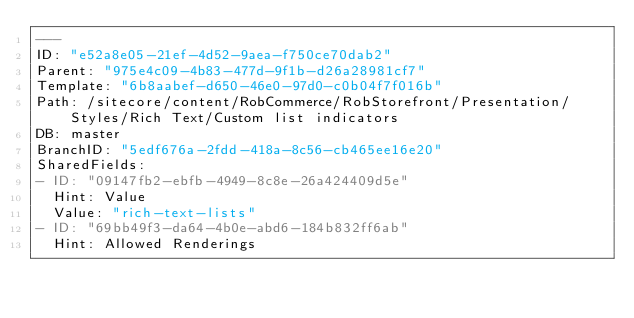Convert code to text. <code><loc_0><loc_0><loc_500><loc_500><_YAML_>---
ID: "e52a8e05-21ef-4d52-9aea-f750ce70dab2"
Parent: "975e4c09-4b83-477d-9f1b-d26a28981cf7"
Template: "6b8aabef-d650-46e0-97d0-c0b04f7f016b"
Path: /sitecore/content/RobCommerce/RobStorefront/Presentation/Styles/Rich Text/Custom list indicators
DB: master
BranchID: "5edf676a-2fdd-418a-8c56-cb465ee16e20"
SharedFields:
- ID: "09147fb2-ebfb-4949-8c8e-26a424409d5e"
  Hint: Value
  Value: "rich-text-lists"
- ID: "69bb49f3-da64-4b0e-abd6-184b832ff6ab"
  Hint: Allowed Renderings</code> 